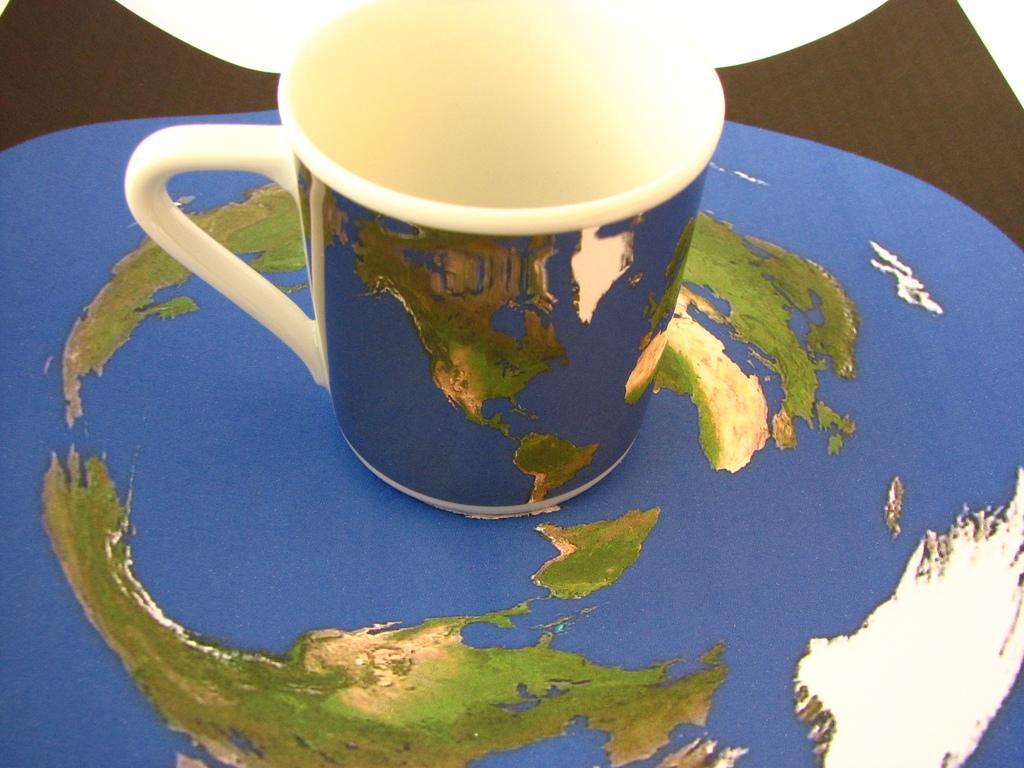How would you summarize this image in a sentence or two? In this image I can see a mug. 